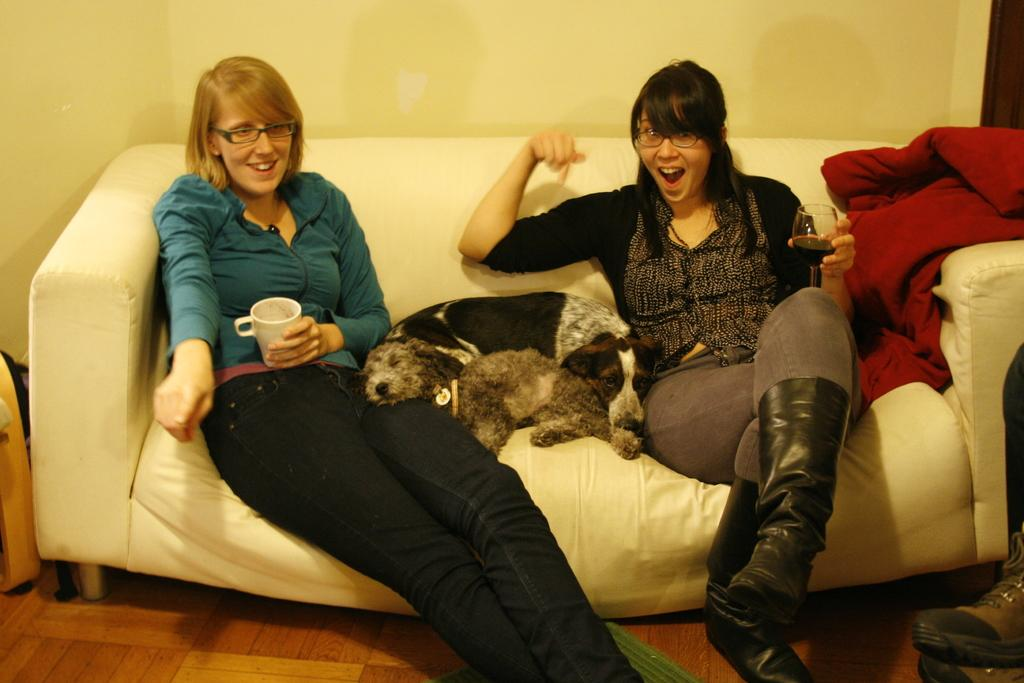How many women are in the image? There are two women in the image. What are the women wearing on their faces? Both women are wearing spectacles. What are the women holding in their hands? One woman is holding a cup, and the other is holding a glass. What is present between the two women? There is a dog between the two women. Where are the women and the dog sitting? They are sitting on a sofa. What can be seen in the background of the image? There is a wall visible in the background of the image. What type of songs can be heard coming from the carriage in the image? There is no carriage present in the image, so it's not possible to determine what, if any, songs might be heard. 